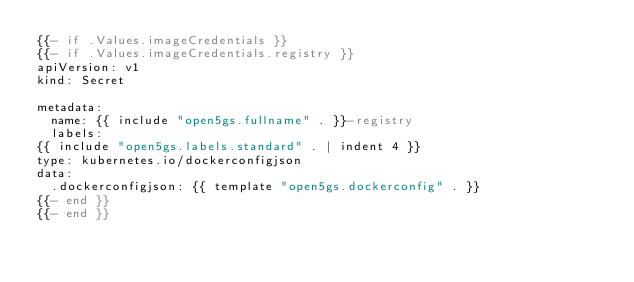<code> <loc_0><loc_0><loc_500><loc_500><_YAML_>{{- if .Values.imageCredentials }}
{{- if .Values.imageCredentials.registry }}
apiVersion: v1
kind: Secret

metadata:
  name: {{ include "open5gs.fullname" . }}-registry
  labels:
{{ include "open5gs.labels.standard" . | indent 4 }}
type: kubernetes.io/dockerconfigjson
data:
  .dockerconfigjson: {{ template "open5gs.dockerconfig" . }}
{{- end }}
{{- end }}</code> 